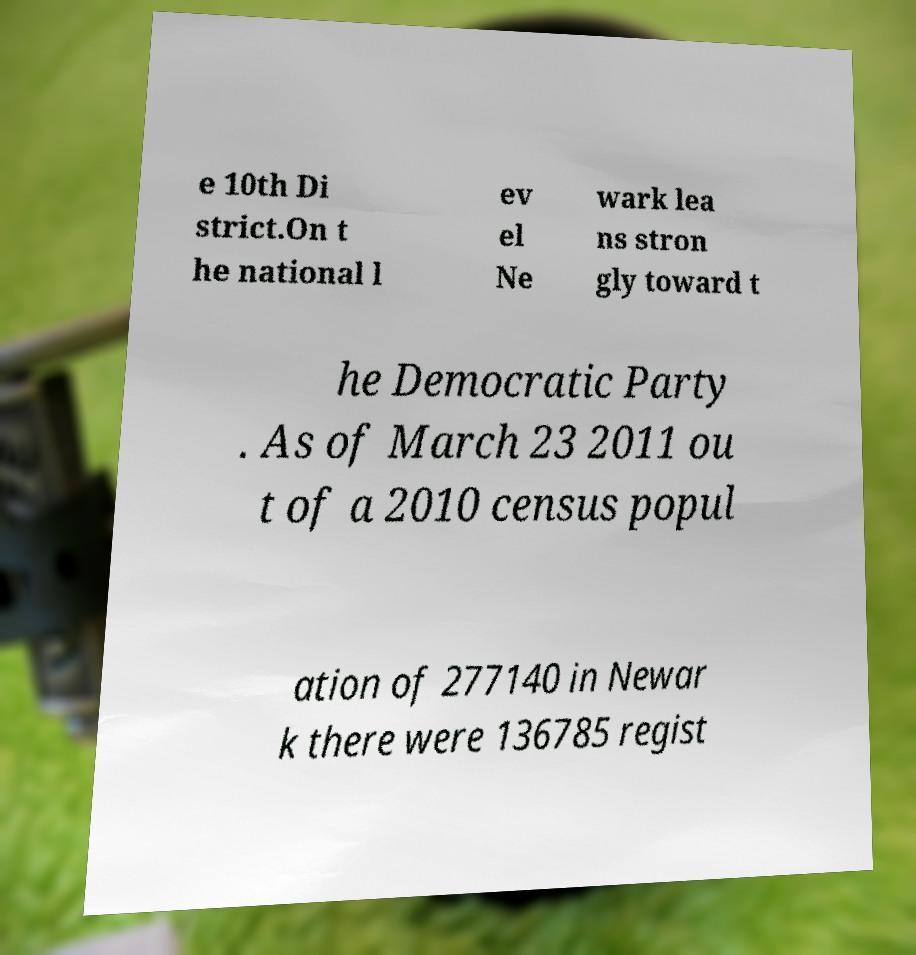There's text embedded in this image that I need extracted. Can you transcribe it verbatim? e 10th Di strict.On t he national l ev el Ne wark lea ns stron gly toward t he Democratic Party . As of March 23 2011 ou t of a 2010 census popul ation of 277140 in Newar k there were 136785 regist 